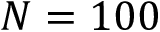<formula> <loc_0><loc_0><loc_500><loc_500>N = 1 0 0</formula> 